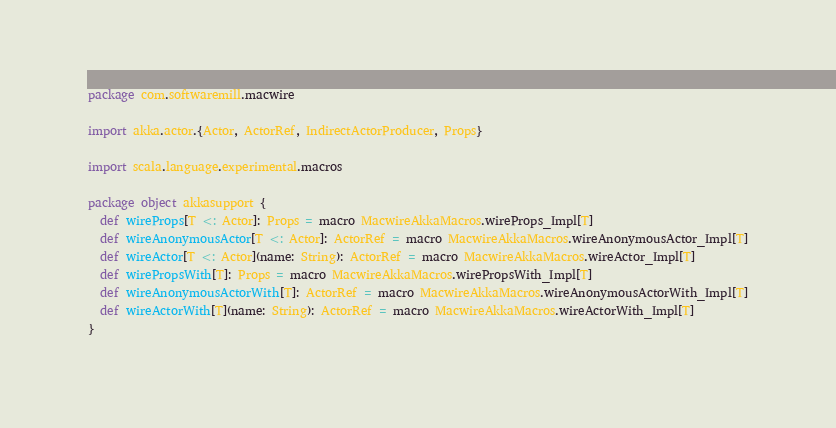Convert code to text. <code><loc_0><loc_0><loc_500><loc_500><_Scala_>package com.softwaremill.macwire

import akka.actor.{Actor, ActorRef, IndirectActorProducer, Props}

import scala.language.experimental.macros

package object akkasupport {
  def wireProps[T <: Actor]: Props = macro MacwireAkkaMacros.wireProps_Impl[T]
  def wireAnonymousActor[T <: Actor]: ActorRef = macro MacwireAkkaMacros.wireAnonymousActor_Impl[T]
  def wireActor[T <: Actor](name: String): ActorRef = macro MacwireAkkaMacros.wireActor_Impl[T]
  def wirePropsWith[T]: Props = macro MacwireAkkaMacros.wirePropsWith_Impl[T]
  def wireAnonymousActorWith[T]: ActorRef = macro MacwireAkkaMacros.wireAnonymousActorWith_Impl[T]
  def wireActorWith[T](name: String): ActorRef = macro MacwireAkkaMacros.wireActorWith_Impl[T]
}
</code> 